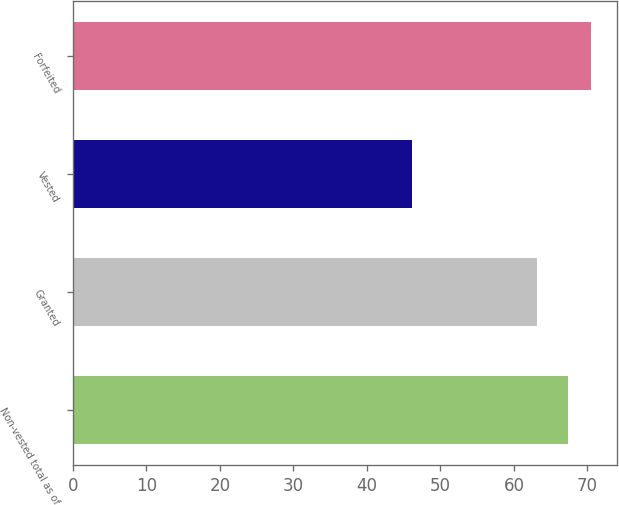Convert chart to OTSL. <chart><loc_0><loc_0><loc_500><loc_500><bar_chart><fcel>Non-vested total as of<fcel>Granted<fcel>Vested<fcel>Forfeited<nl><fcel>67.33<fcel>63.1<fcel>46.1<fcel>70.5<nl></chart> 